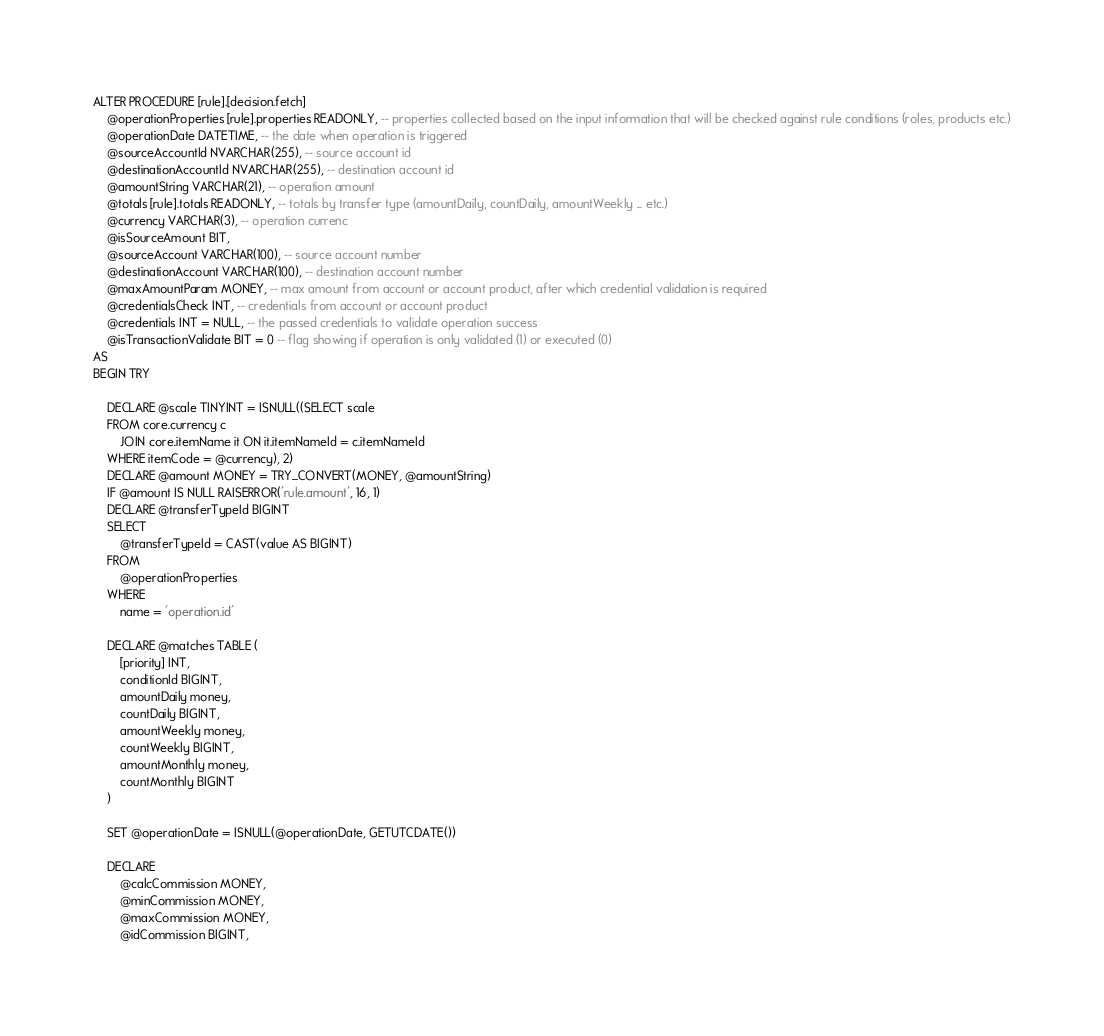<code> <loc_0><loc_0><loc_500><loc_500><_SQL_>ALTER PROCEDURE [rule].[decision.fetch]
    @operationProperties [rule].properties READONLY, -- properties collected based on the input information that will be checked against rule conditions (roles, products etc.)
    @operationDate DATETIME, -- the date when operation is triggered
    @sourceAccountId NVARCHAR(255), -- source account id
    @destinationAccountId NVARCHAR(255), -- destination account id
    @amountString VARCHAR(21), -- operation amount
    @totals [rule].totals READONLY, -- totals by transfer type (amountDaily, countDaily, amountWeekly ... etc.)
    @currency VARCHAR(3), -- operation currenc
    @isSourceAmount BIT,
    @sourceAccount VARCHAR(100), -- source account number
    @destinationAccount VARCHAR(100), -- destination account number
    @maxAmountParam MONEY, -- max amount from account or account product, after which credential validation is required
    @credentialsCheck INT, -- credentials from account or account product
    @credentials INT = NULL, -- the passed credentials to validate operation success
    @isTransactionValidate BIT = 0 -- flag showing if operation is only validated (1) or executed (0)
AS
BEGIN TRY

    DECLARE @scale TINYINT = ISNULL((SELECT scale
    FROM core.currency c
        JOIN core.itemName it ON it.itemNameId = c.itemNameId
    WHERE itemCode = @currency), 2)
    DECLARE @amount MONEY = TRY_CONVERT(MONEY, @amountString)
    IF @amount IS NULL RAISERROR('rule.amount', 16, 1)
    DECLARE @transferTypeId BIGINT
    SELECT
        @transferTypeId = CAST(value AS BIGINT)
    FROM
        @operationProperties
    WHERE
        name = 'operation.id'

    DECLARE @matches TABLE (
        [priority] INT,
        conditionId BIGINT,
        amountDaily money,
        countDaily BIGINT,
        amountWeekly money,
        countWeekly BIGINT,
        amountMonthly money,
        countMonthly BIGINT
    )

    SET @operationDate = ISNULL(@operationDate, GETUTCDATE())

    DECLARE
        @calcCommission MONEY,
        @minCommission MONEY,
        @maxCommission MONEY,
        @idCommission BIGINT,</code> 